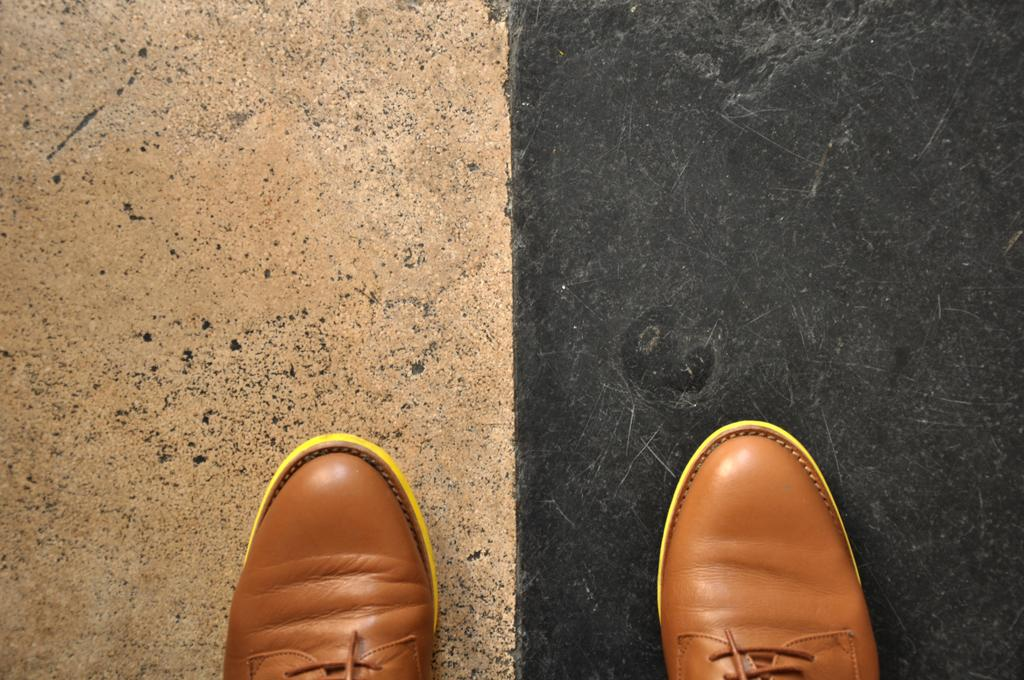What objects are on the ground in the image? There are shoes on the ground in the image. How many pizzas are being served on the marble table in the image? There is no mention of pizzas or a marble table in the image; it only features shoes on the ground. 